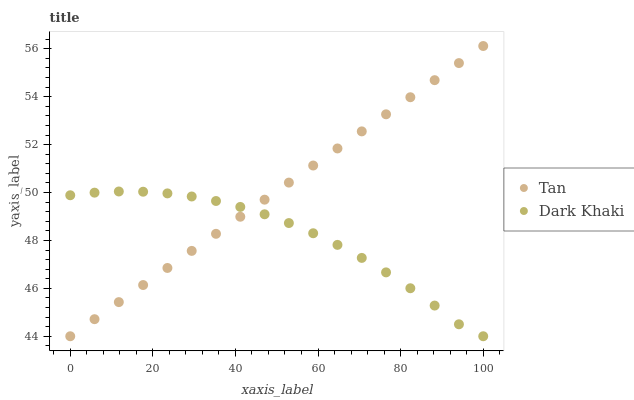Does Dark Khaki have the minimum area under the curve?
Answer yes or no. Yes. Does Tan have the maximum area under the curve?
Answer yes or no. Yes. Does Tan have the minimum area under the curve?
Answer yes or no. No. Is Tan the smoothest?
Answer yes or no. Yes. Is Dark Khaki the roughest?
Answer yes or no. Yes. Is Tan the roughest?
Answer yes or no. No. Does Dark Khaki have the lowest value?
Answer yes or no. Yes. Does Tan have the highest value?
Answer yes or no. Yes. Does Dark Khaki intersect Tan?
Answer yes or no. Yes. Is Dark Khaki less than Tan?
Answer yes or no. No. Is Dark Khaki greater than Tan?
Answer yes or no. No. 